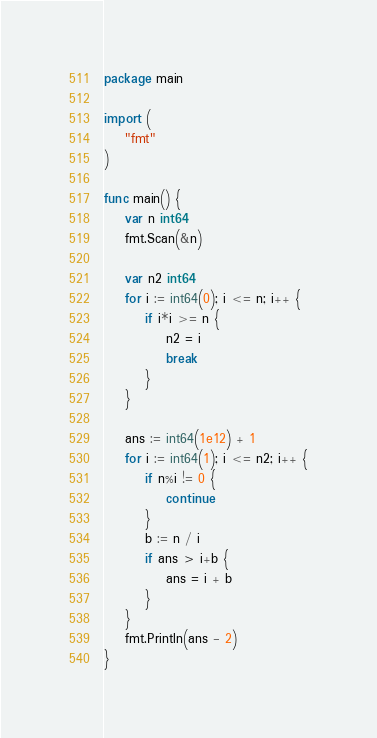<code> <loc_0><loc_0><loc_500><loc_500><_Go_>package main

import (
	"fmt"
)

func main() {
	var n int64
	fmt.Scan(&n)

	var n2 int64
	for i := int64(0); i <= n; i++ {
		if i*i >= n {
			n2 = i
			break
		}
	}

	ans := int64(1e12) + 1
	for i := int64(1); i <= n2; i++ {
		if n%i != 0 {
			continue
		}
		b := n / i
		if ans > i+b {
			ans = i + b
		}
	}
	fmt.Println(ans - 2)
}
</code> 